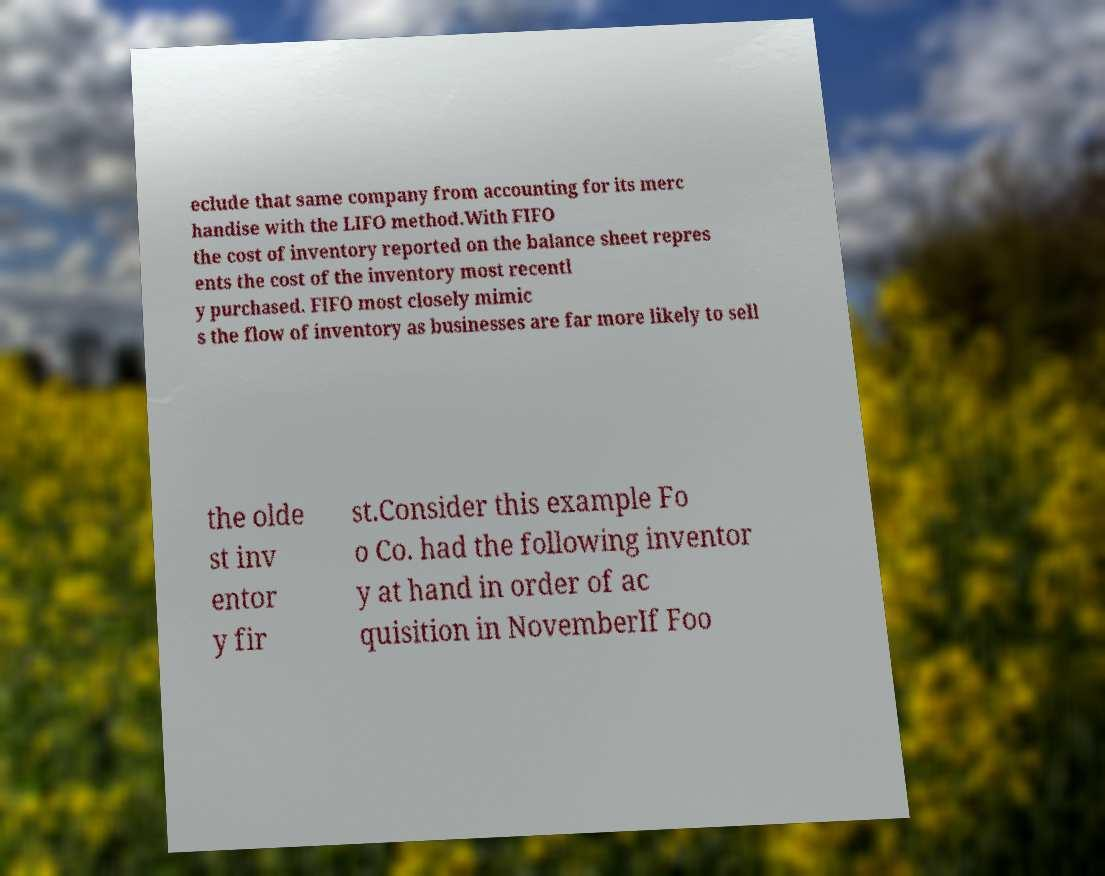What messages or text are displayed in this image? I need them in a readable, typed format. eclude that same company from accounting for its merc handise with the LIFO method.With FIFO the cost of inventory reported on the balance sheet repres ents the cost of the inventory most recentl y purchased. FIFO most closely mimic s the flow of inventory as businesses are far more likely to sell the olde st inv entor y fir st.Consider this example Fo o Co. had the following inventor y at hand in order of ac quisition in NovemberIf Foo 